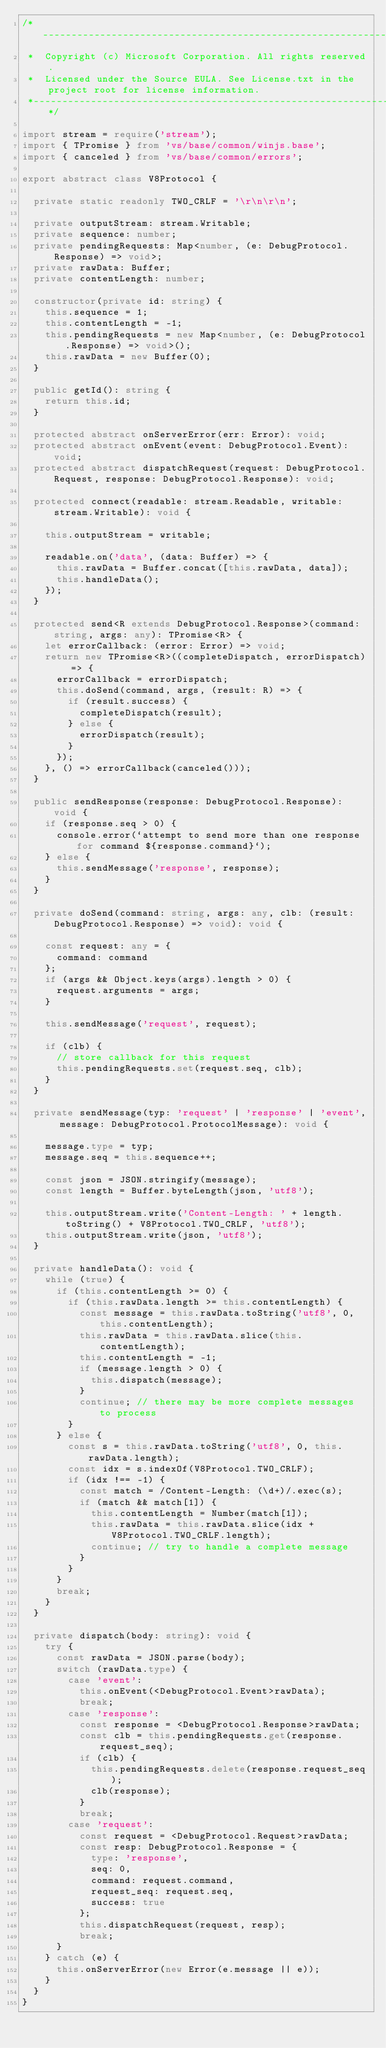Convert code to text. <code><loc_0><loc_0><loc_500><loc_500><_TypeScript_>/*---------------------------------------------------------------------------------------------
 *  Copyright (c) Microsoft Corporation. All rights reserved.
 *  Licensed under the Source EULA. See License.txt in the project root for license information.
 *--------------------------------------------------------------------------------------------*/

import stream = require('stream');
import { TPromise } from 'vs/base/common/winjs.base';
import { canceled } from 'vs/base/common/errors';

export abstract class V8Protocol {

	private static readonly TWO_CRLF = '\r\n\r\n';

	private outputStream: stream.Writable;
	private sequence: number;
	private pendingRequests: Map<number, (e: DebugProtocol.Response) => void>;
	private rawData: Buffer;
	private contentLength: number;

	constructor(private id: string) {
		this.sequence = 1;
		this.contentLength = -1;
		this.pendingRequests = new Map<number, (e: DebugProtocol.Response) => void>();
		this.rawData = new Buffer(0);
	}

	public getId(): string {
		return this.id;
	}

	protected abstract onServerError(err: Error): void;
	protected abstract onEvent(event: DebugProtocol.Event): void;
	protected abstract dispatchRequest(request: DebugProtocol.Request, response: DebugProtocol.Response): void;

	protected connect(readable: stream.Readable, writable: stream.Writable): void {

		this.outputStream = writable;

		readable.on('data', (data: Buffer) => {
			this.rawData = Buffer.concat([this.rawData, data]);
			this.handleData();
		});
	}

	protected send<R extends DebugProtocol.Response>(command: string, args: any): TPromise<R> {
		let errorCallback: (error: Error) => void;
		return new TPromise<R>((completeDispatch, errorDispatch) => {
			errorCallback = errorDispatch;
			this.doSend(command, args, (result: R) => {
				if (result.success) {
					completeDispatch(result);
				} else {
					errorDispatch(result);
				}
			});
		}, () => errorCallback(canceled()));
	}

	public sendResponse(response: DebugProtocol.Response): void {
		if (response.seq > 0) {
			console.error(`attempt to send more than one response for command ${response.command}`);
		} else {
			this.sendMessage('response', response);
		}
	}

	private doSend(command: string, args: any, clb: (result: DebugProtocol.Response) => void): void {

		const request: any = {
			command: command
		};
		if (args && Object.keys(args).length > 0) {
			request.arguments = args;
		}

		this.sendMessage('request', request);

		if (clb) {
			// store callback for this request
			this.pendingRequests.set(request.seq, clb);
		}
	}

	private sendMessage(typ: 'request' | 'response' | 'event', message: DebugProtocol.ProtocolMessage): void {

		message.type = typ;
		message.seq = this.sequence++;

		const json = JSON.stringify(message);
		const length = Buffer.byteLength(json, 'utf8');

		this.outputStream.write('Content-Length: ' + length.toString() + V8Protocol.TWO_CRLF, 'utf8');
		this.outputStream.write(json, 'utf8');
	}

	private handleData(): void {
		while (true) {
			if (this.contentLength >= 0) {
				if (this.rawData.length >= this.contentLength) {
					const message = this.rawData.toString('utf8', 0, this.contentLength);
					this.rawData = this.rawData.slice(this.contentLength);
					this.contentLength = -1;
					if (message.length > 0) {
						this.dispatch(message);
					}
					continue;	// there may be more complete messages to process
				}
			} else {
				const s = this.rawData.toString('utf8', 0, this.rawData.length);
				const idx = s.indexOf(V8Protocol.TWO_CRLF);
				if (idx !== -1) {
					const match = /Content-Length: (\d+)/.exec(s);
					if (match && match[1]) {
						this.contentLength = Number(match[1]);
						this.rawData = this.rawData.slice(idx + V8Protocol.TWO_CRLF.length);
						continue;	// try to handle a complete message
					}
				}
			}
			break;
		}
	}

	private dispatch(body: string): void {
		try {
			const rawData = JSON.parse(body);
			switch (rawData.type) {
				case 'event':
					this.onEvent(<DebugProtocol.Event>rawData);
					break;
				case 'response':
					const response = <DebugProtocol.Response>rawData;
					const clb = this.pendingRequests.get(response.request_seq);
					if (clb) {
						this.pendingRequests.delete(response.request_seq);
						clb(response);
					}
					break;
				case 'request':
					const request = <DebugProtocol.Request>rawData;
					const resp: DebugProtocol.Response = {
						type: 'response',
						seq: 0,
						command: request.command,
						request_seq: request.seq,
						success: true
					};
					this.dispatchRequest(request, resp);
					break;
			}
		} catch (e) {
			this.onServerError(new Error(e.message || e));
		}
	}
}
</code> 